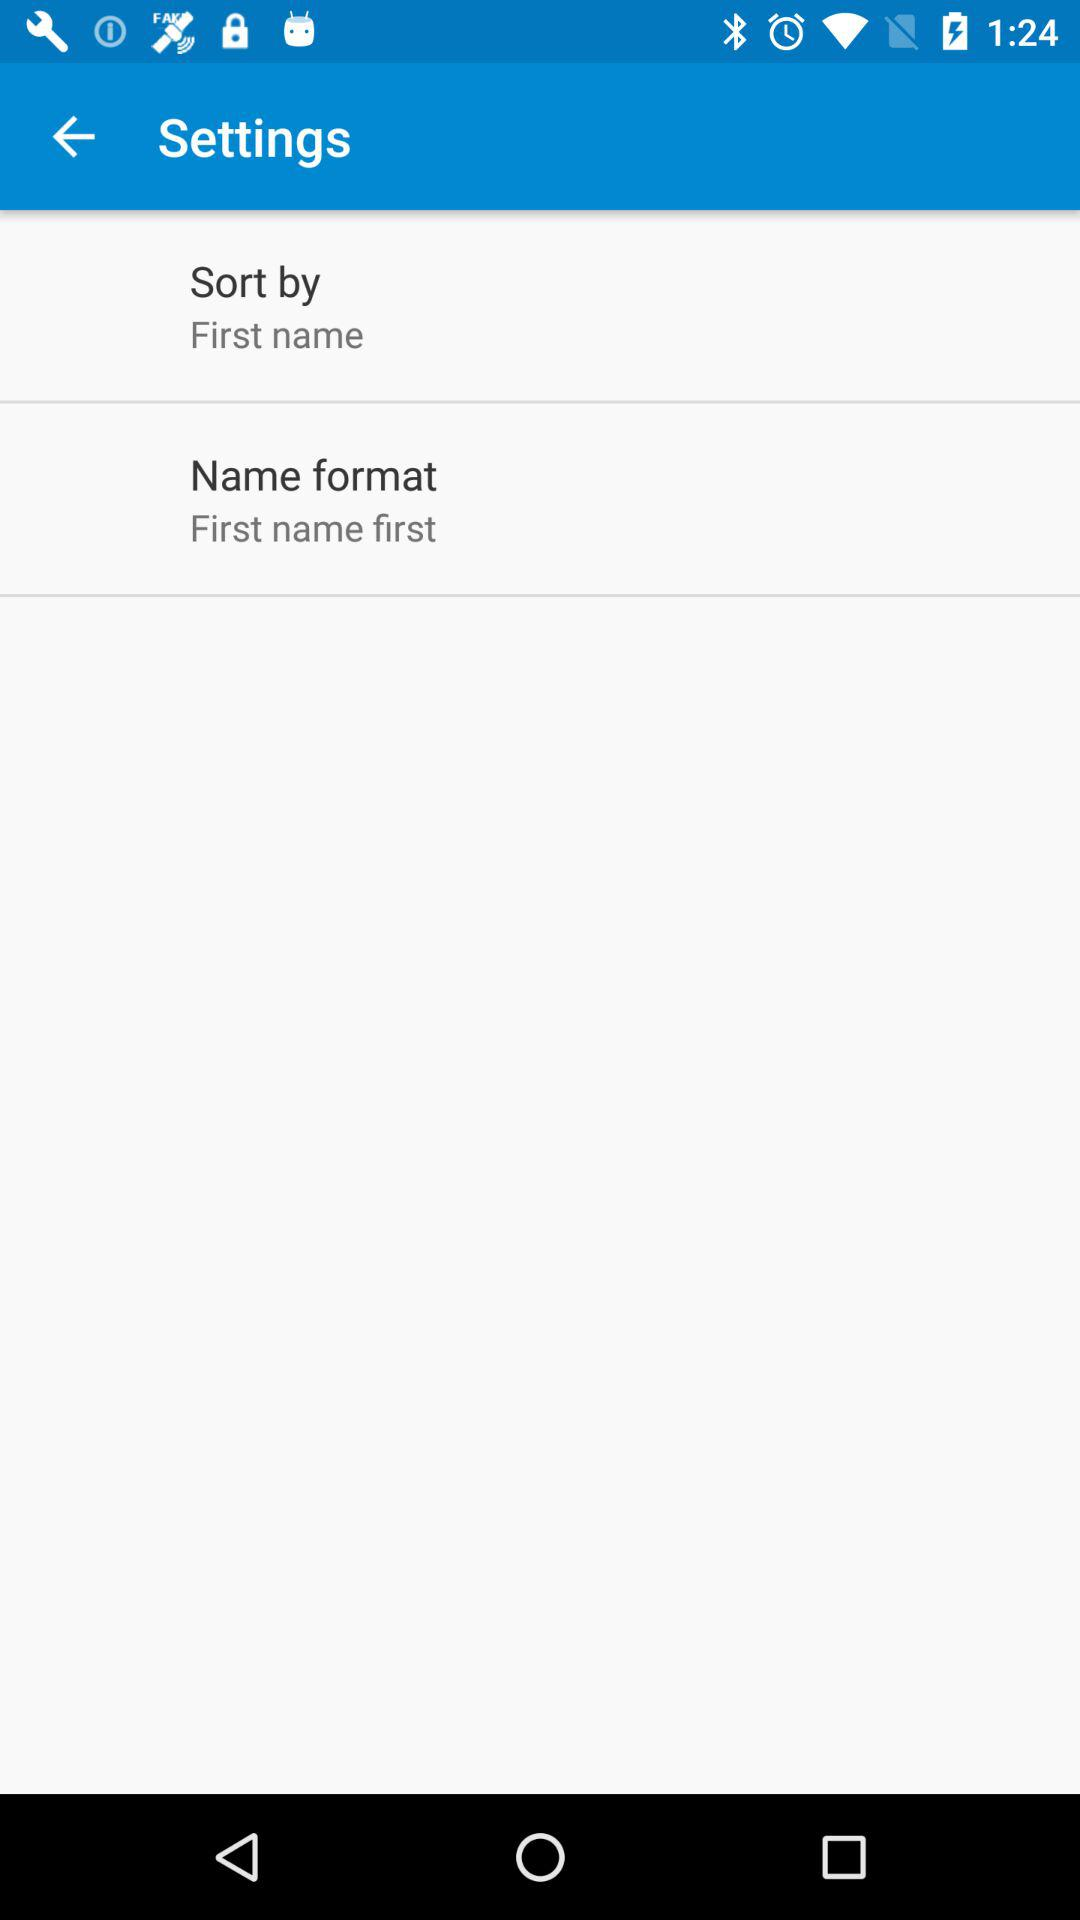How many more items are there in the settings menu than in the sort by menu?
Answer the question using a single word or phrase. 1 